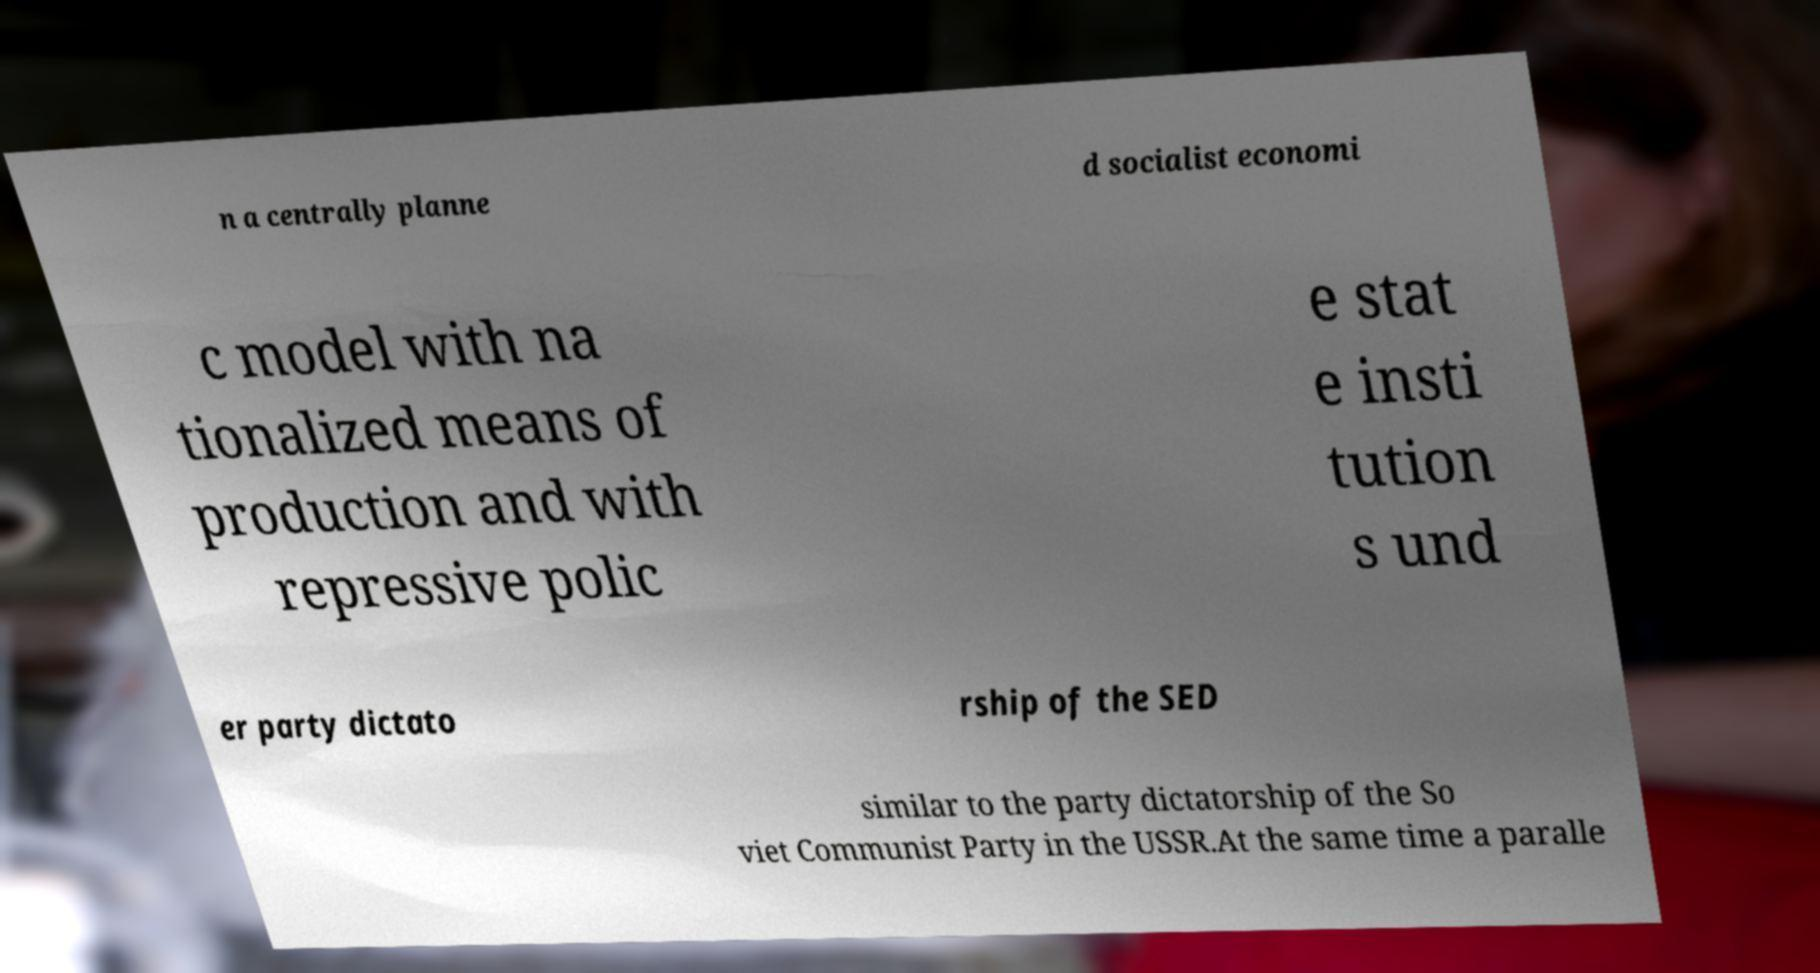I need the written content from this picture converted into text. Can you do that? n a centrally planne d socialist economi c model with na tionalized means of production and with repressive polic e stat e insti tution s und er party dictato rship of the SED similar to the party dictatorship of the So viet Communist Party in the USSR.At the same time a paralle 